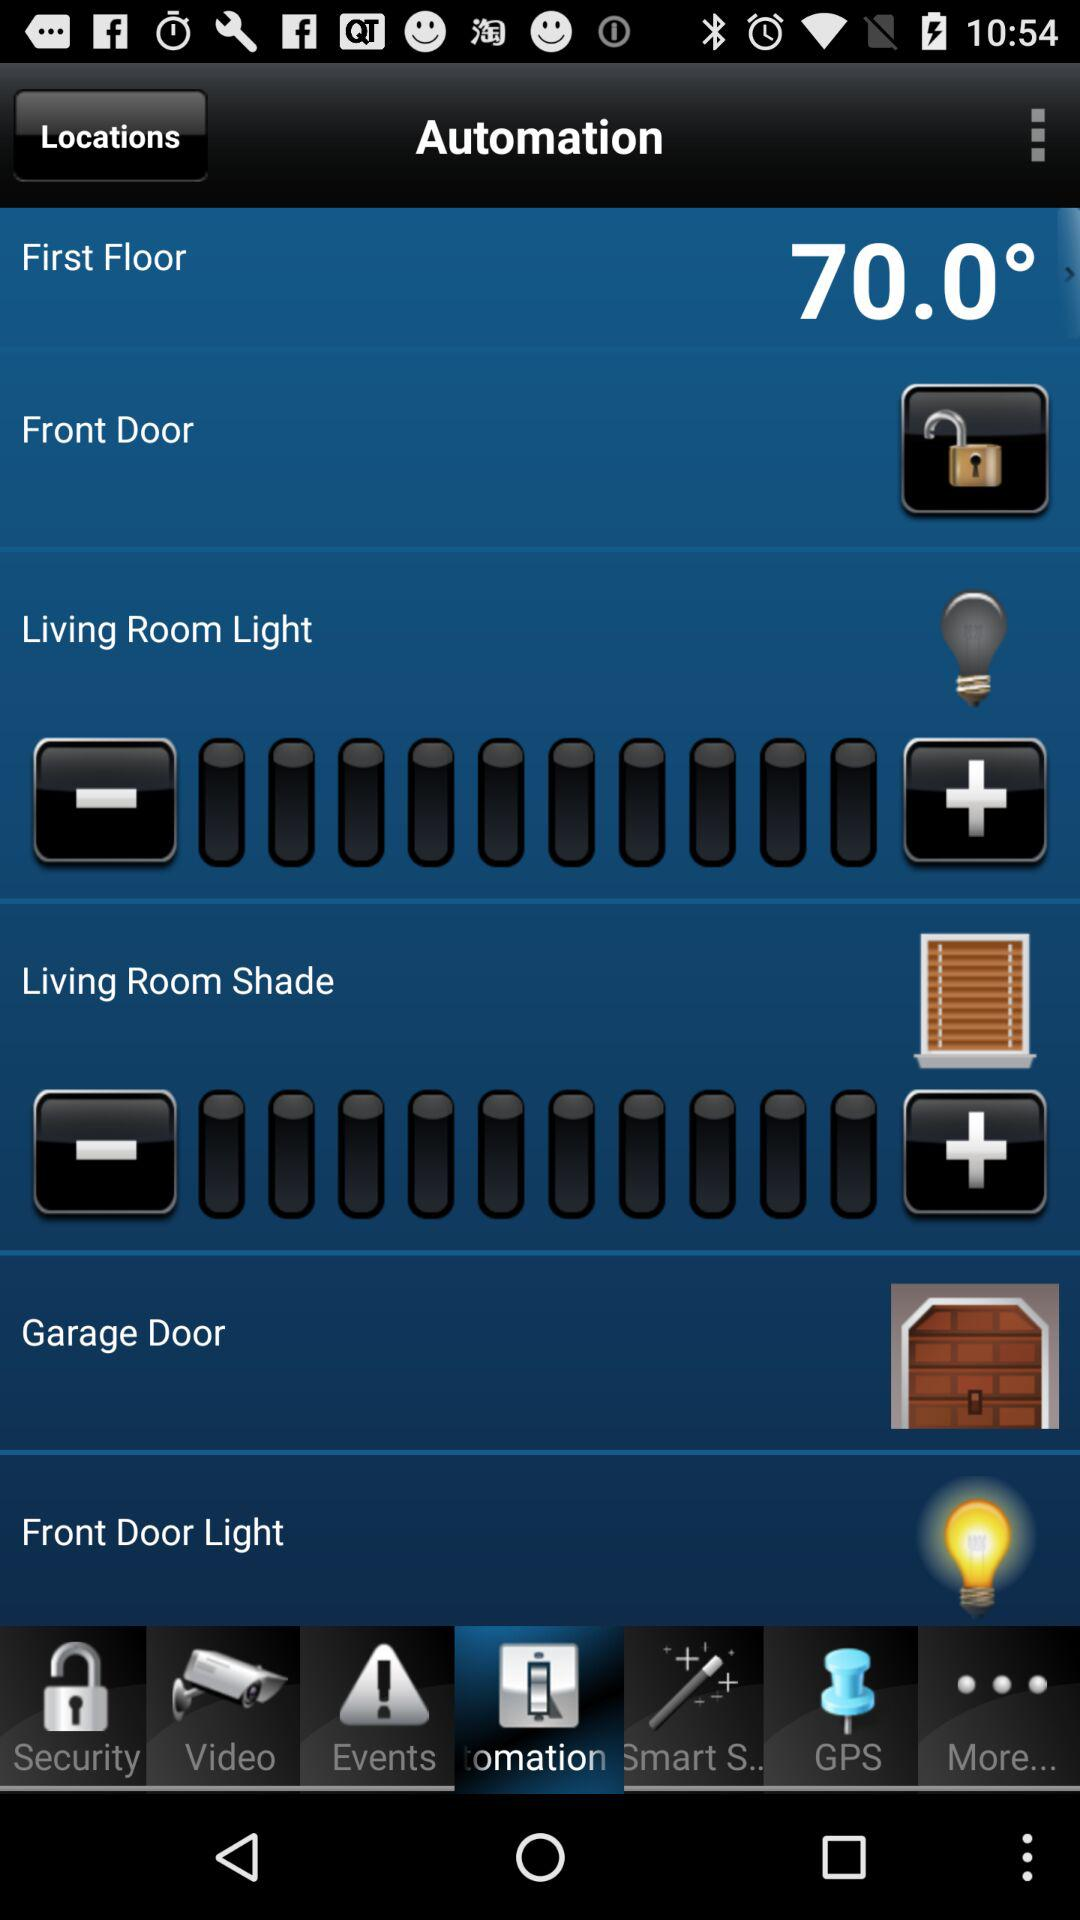How much is the temperature on the first floor? The temperature is 70 degrees. 